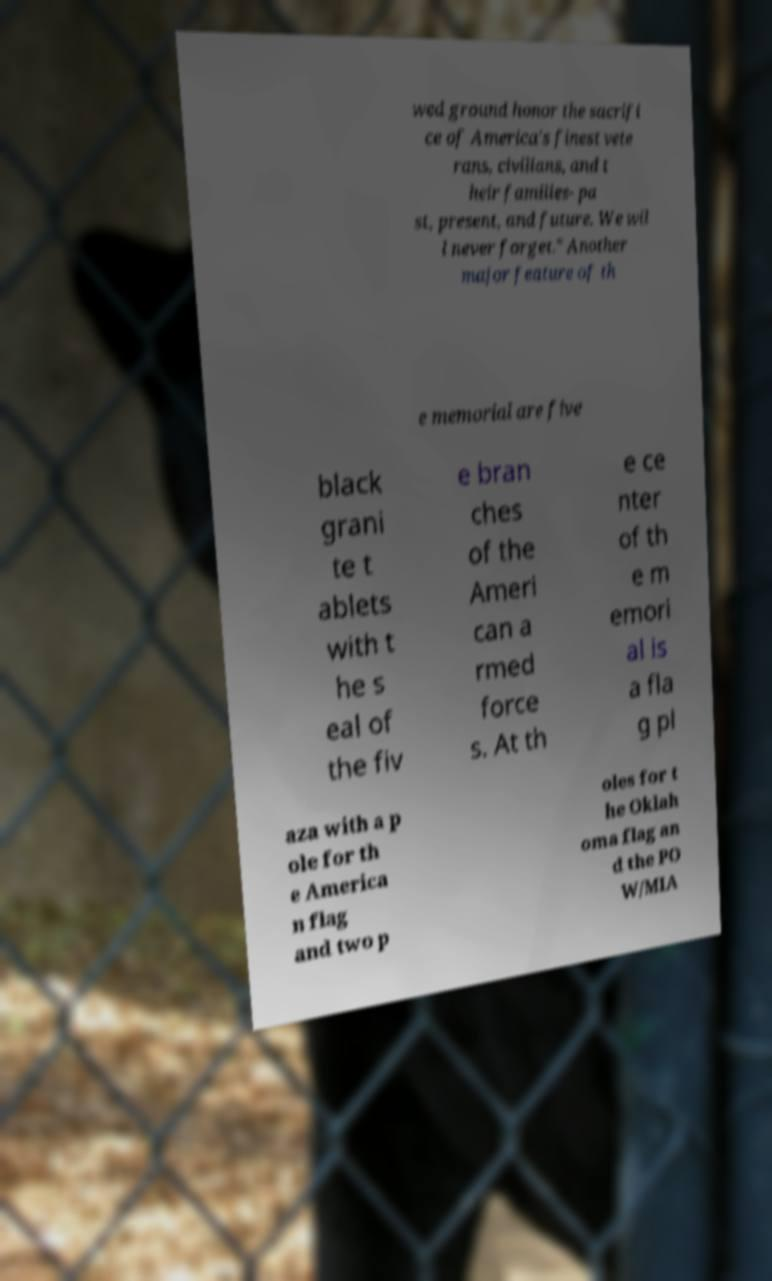Can you accurately transcribe the text from the provided image for me? wed ground honor the sacrifi ce of America's finest vete rans, civilians, and t heir families- pa st, present, and future. We wil l never forget." Another major feature of th e memorial are five black grani te t ablets with t he s eal of the fiv e bran ches of the Ameri can a rmed force s. At th e ce nter of th e m emori al is a fla g pl aza with a p ole for th e America n flag and two p oles for t he Oklah oma flag an d the PO W/MIA 